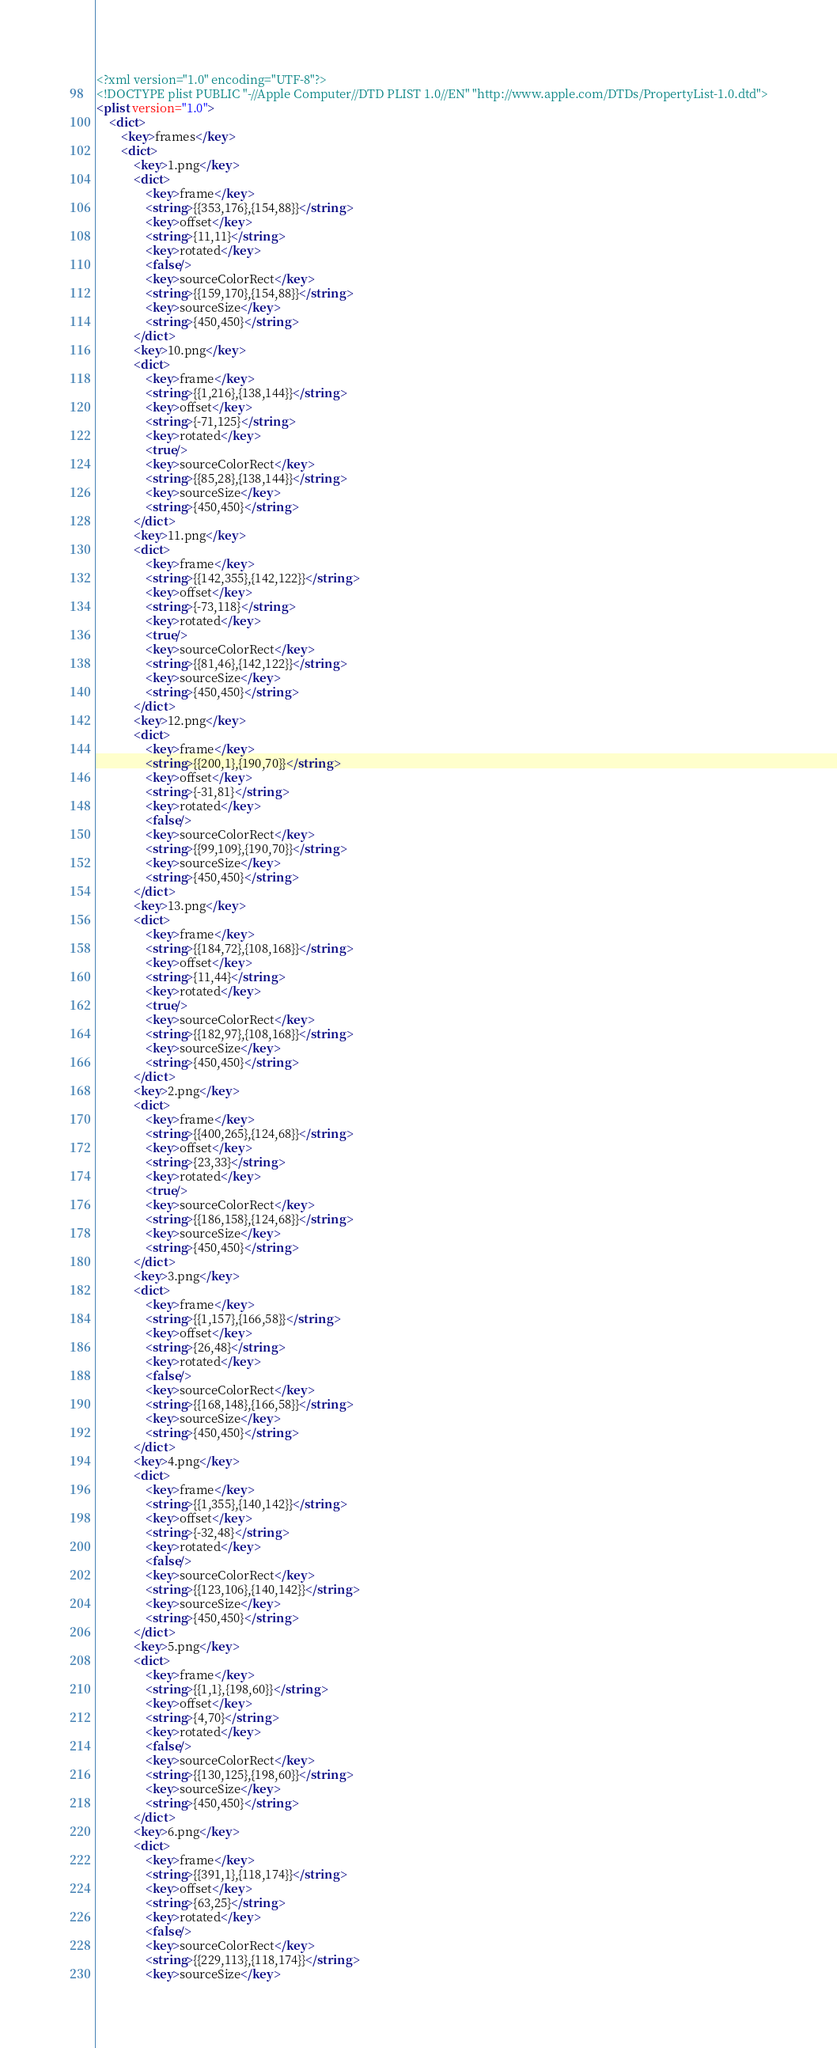Convert code to text. <code><loc_0><loc_0><loc_500><loc_500><_XML_><?xml version="1.0" encoding="UTF-8"?>
<!DOCTYPE plist PUBLIC "-//Apple Computer//DTD PLIST 1.0//EN" "http://www.apple.com/DTDs/PropertyList-1.0.dtd">
<plist version="1.0">
    <dict>
        <key>frames</key>
        <dict>
            <key>1.png</key>
            <dict>
                <key>frame</key>
                <string>{{353,176},{154,88}}</string>
                <key>offset</key>
                <string>{11,11}</string>
                <key>rotated</key>
                <false/>
                <key>sourceColorRect</key>
                <string>{{159,170},{154,88}}</string>
                <key>sourceSize</key>
                <string>{450,450}</string>
            </dict>
            <key>10.png</key>
            <dict>
                <key>frame</key>
                <string>{{1,216},{138,144}}</string>
                <key>offset</key>
                <string>{-71,125}</string>
                <key>rotated</key>
                <true/>
                <key>sourceColorRect</key>
                <string>{{85,28},{138,144}}</string>
                <key>sourceSize</key>
                <string>{450,450}</string>
            </dict>
            <key>11.png</key>
            <dict>
                <key>frame</key>
                <string>{{142,355},{142,122}}</string>
                <key>offset</key>
                <string>{-73,118}</string>
                <key>rotated</key>
                <true/>
                <key>sourceColorRect</key>
                <string>{{81,46},{142,122}}</string>
                <key>sourceSize</key>
                <string>{450,450}</string>
            </dict>
            <key>12.png</key>
            <dict>
                <key>frame</key>
                <string>{{200,1},{190,70}}</string>
                <key>offset</key>
                <string>{-31,81}</string>
                <key>rotated</key>
                <false/>
                <key>sourceColorRect</key>
                <string>{{99,109},{190,70}}</string>
                <key>sourceSize</key>
                <string>{450,450}</string>
            </dict>
            <key>13.png</key>
            <dict>
                <key>frame</key>
                <string>{{184,72},{108,168}}</string>
                <key>offset</key>
                <string>{11,44}</string>
                <key>rotated</key>
                <true/>
                <key>sourceColorRect</key>
                <string>{{182,97},{108,168}}</string>
                <key>sourceSize</key>
                <string>{450,450}</string>
            </dict>
            <key>2.png</key>
            <dict>
                <key>frame</key>
                <string>{{400,265},{124,68}}</string>
                <key>offset</key>
                <string>{23,33}</string>
                <key>rotated</key>
                <true/>
                <key>sourceColorRect</key>
                <string>{{186,158},{124,68}}</string>
                <key>sourceSize</key>
                <string>{450,450}</string>
            </dict>
            <key>3.png</key>
            <dict>
                <key>frame</key>
                <string>{{1,157},{166,58}}</string>
                <key>offset</key>
                <string>{26,48}</string>
                <key>rotated</key>
                <false/>
                <key>sourceColorRect</key>
                <string>{{168,148},{166,58}}</string>
                <key>sourceSize</key>
                <string>{450,450}</string>
            </dict>
            <key>4.png</key>
            <dict>
                <key>frame</key>
                <string>{{1,355},{140,142}}</string>
                <key>offset</key>
                <string>{-32,48}</string>
                <key>rotated</key>
                <false/>
                <key>sourceColorRect</key>
                <string>{{123,106},{140,142}}</string>
                <key>sourceSize</key>
                <string>{450,450}</string>
            </dict>
            <key>5.png</key>
            <dict>
                <key>frame</key>
                <string>{{1,1},{198,60}}</string>
                <key>offset</key>
                <string>{4,70}</string>
                <key>rotated</key>
                <false/>
                <key>sourceColorRect</key>
                <string>{{130,125},{198,60}}</string>
                <key>sourceSize</key>
                <string>{450,450}</string>
            </dict>
            <key>6.png</key>
            <dict>
                <key>frame</key>
                <string>{{391,1},{118,174}}</string>
                <key>offset</key>
                <string>{63,25}</string>
                <key>rotated</key>
                <false/>
                <key>sourceColorRect</key>
                <string>{{229,113},{118,174}}</string>
                <key>sourceSize</key></code> 